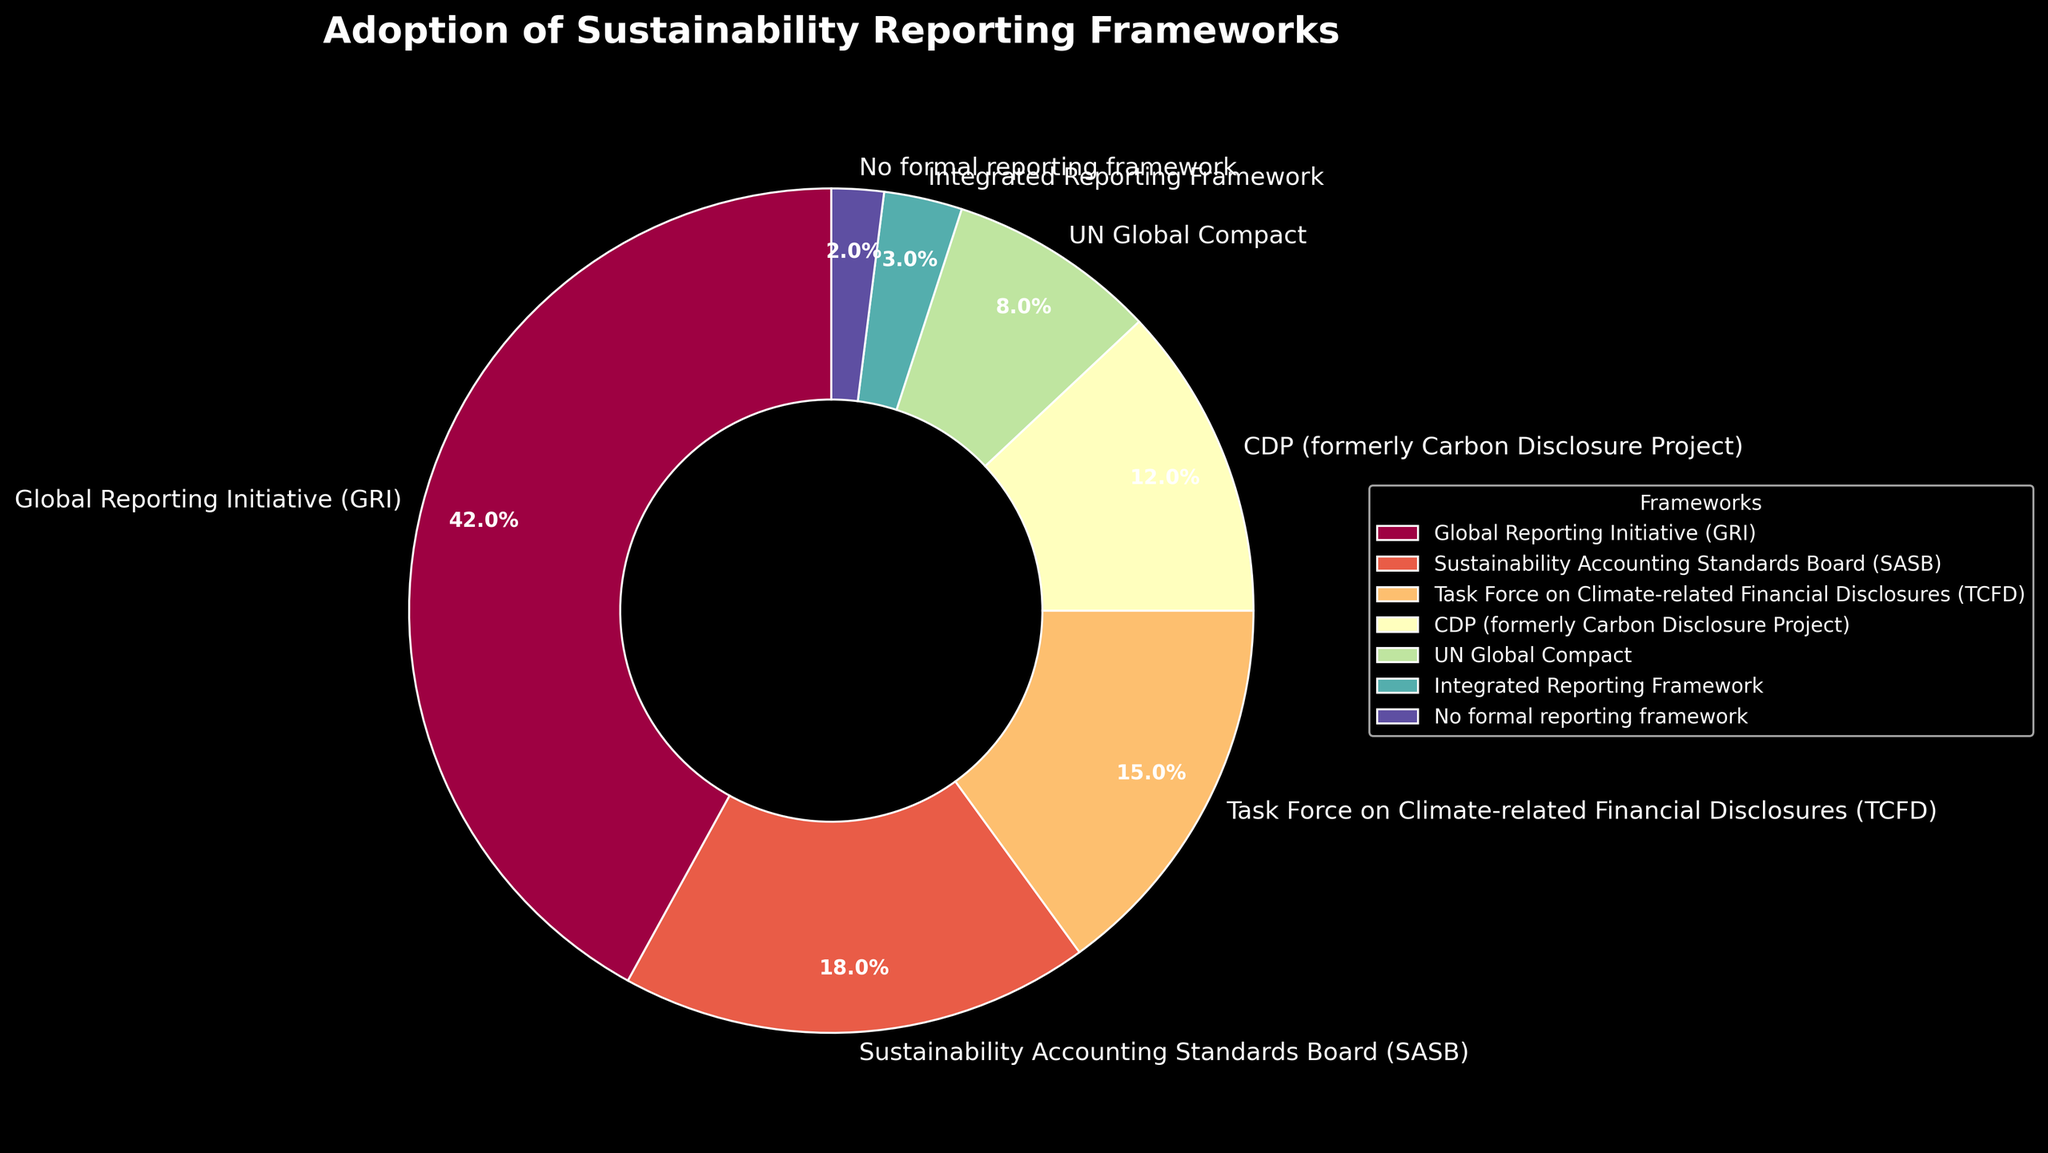What's the total percentage of companies adopting GRI, SASB, and TCFD frameworks? Sum the percentages of companies adopting the GRI (42%), SASB (18%), and TCFD (15%) frameworks: 42% + 18% + 15% = 75%
Answer: 75% Which framework has the highest adoption rate? Compare the percentages of all frameworks. The GRI has the highest at 42%
Answer: Global Reporting Initiative (GRI) How many times more companies adopt the GRI framework compared to those that use no formal reporting framework? Divide the percentage for GRI (42%) by the percentage for no formal framework (2%): 42 / 2 = 21
Answer: 21 times What is the combined percentage of companies adopting either CDP or the UN Global Compact frameworks? Add the percentages for CDP (12%) and the UN Global Compact (8%): 12% + 8% = 20%
Answer: 20% Which frameworks are adopted by 15% or more companies? Identify frameworks with percentages of 15% or more: GRI (42%), SASB (18%), and TCFD (15%)
Answer: Global Reporting Initiative (GRI), Sustainability Accounting Standards Board (SASB), Task Force on Climate-related Financial Disclosures (TCFD) How much more popular is the GRI framework compared to the TCFD framework? Subtract the percentage of TCFD (15%) from the percentage of GRI (42%): 42% - 15% = 27%
Answer: 27% Which framework has the smallest adoption rate, excluding "No formal reporting framework"? Compare the percentages of all specific frameworks except "No formal reporting framework." The Integrated Reporting Framework is the smallest at 3%
Answer: Integrated Reporting Framework What is the difference in adoption rates between the two least adopted specific frameworks? Subtract the percentage of the least adopted "No formal reporting framework" (2%) from the percentage of the second least adopted "Integrated Reporting Framework" (3%): 3% - 2% = 1%
Answer: 1% What is the average adoption rate for all the frameworks listed in the chart? Sum the percentages of all frameworks (42% + 18% + 15% + 12% + 8% + 3% + 2% = 100%), then divide by the number of frameworks (7): 100% / 7 ≈ 14.29%
Answer: 14.29% Which framework exhibits a visually distinctive color, making it easy to identify in the pie chart? Describe the most visually distinct color in the pie chart. This might depend on the color mapping used, but generally, one will stand out more.
Answer: Spectrally distinctive color (answer may vary based on visualization) 